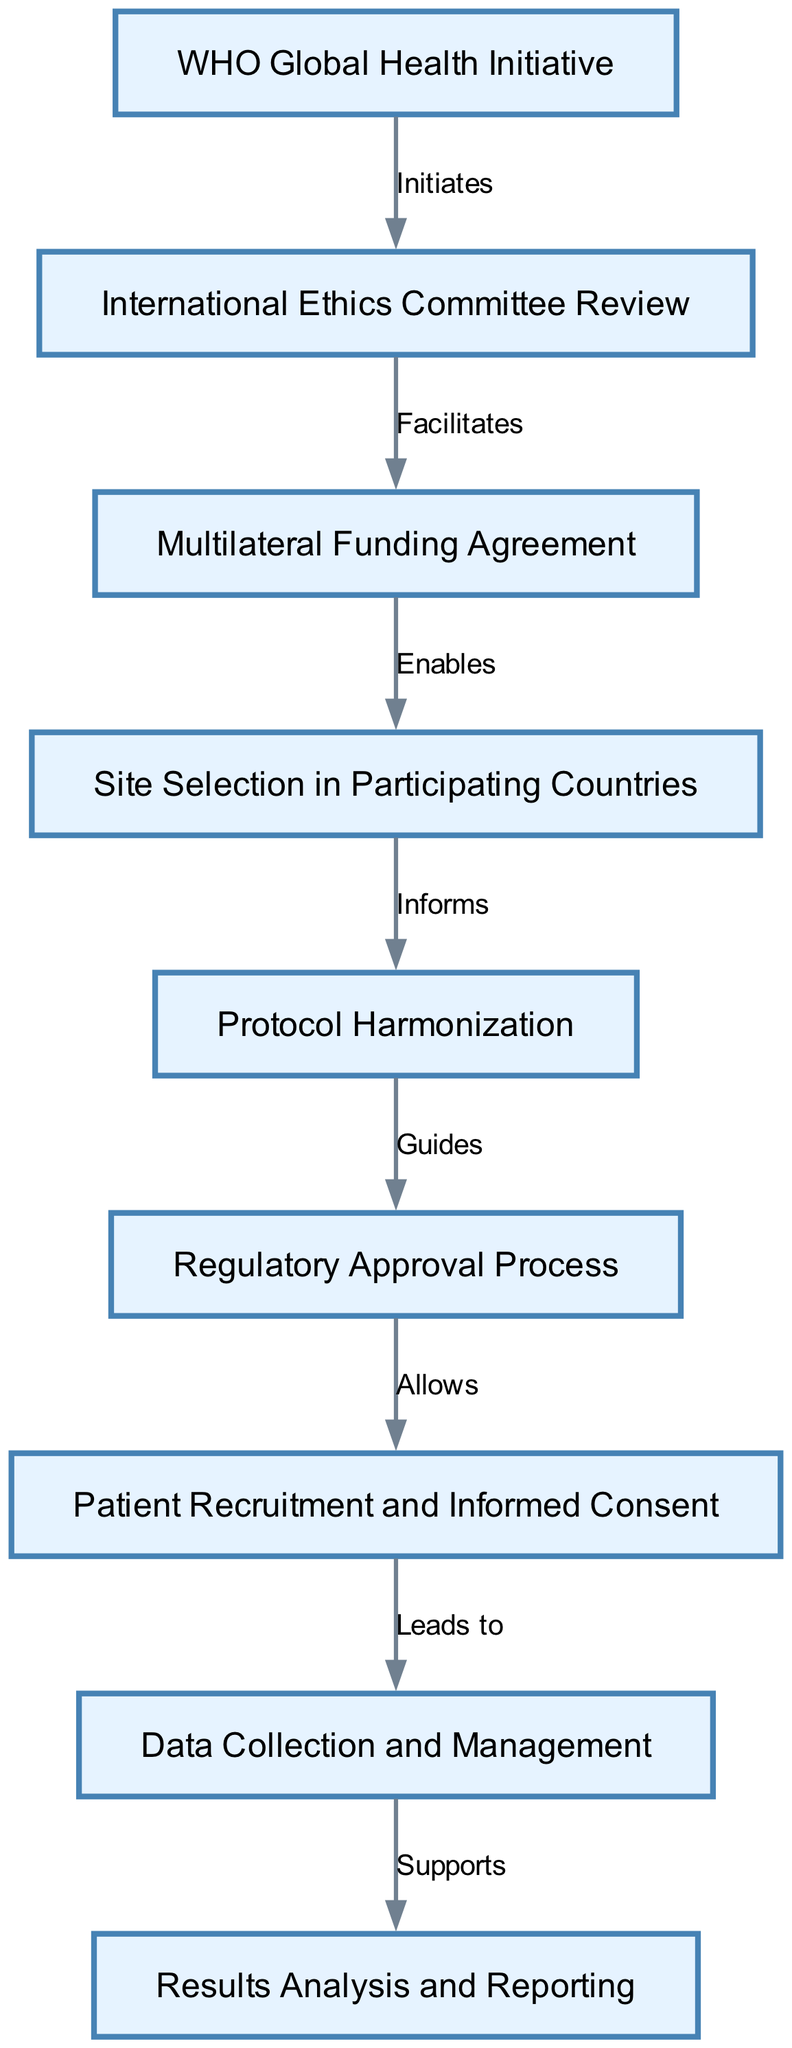What is the first step in the pathway? The first step in the pathway is initiated by the WHO Global Health Initiative, which sets the process in motion.
Answer: WHO Global Health Initiative How many nodes are in the clinical pathway diagram? The diagram contains a total of nine nodes, each representing a key element in the multinational clinical trial coordination pathway.
Answer: 9 Which node follows the International Ethics Committee Review? The node that follows the International Ethics Committee Review is the Multilateral Funding Agreement, as indicated by the directed edge connecting them.
Answer: Multilateral Funding Agreement What relationship does Site Selection in Participating Countries have with Protocol Harmonization? Site Selection in Participating Countries informs Protocol Harmonization, meaning that the selection process impacts how the study protocols are coordinated and standardized.
Answer: Informs What enables the Site Selection in Participating Countries? The enabling factor for Site Selection in Participating Countries is the Multilateral Funding Agreement, which provides the necessary resources and financial backing for the selection process.
Answer: Multilateral Funding Agreement Which process allows for Patient Recruitment and Informed Consent? The Regulatory Approval Process allows for Patient Recruitment and Informed Consent, as approval is required before recruitment can legally proceed.
Answer: Regulatory Approval Process What does Data Collection and Management support? Data Collection and Management supports the Results Analysis and Reporting process, as the data gathered is essential for analyzing and reporting the trial outcomes.
Answer: Results Analysis and Reporting How many edges are present in the diagram? The diagram features a total of eight edges, each representing a distinct relationship between the nodes that detail the flow of the clinical pathway.
Answer: 8 Which node is directly linked to Results Analysis and Reporting? The node directly linked to Results Analysis and Reporting is Data Collection and Management, which directly precedes it in the flow.
Answer: Data Collection and Management What guides the Regulatory Approval Process? The Protocol Harmonization guides the Regulatory Approval Process by ensuring that the study protocols are aligned with regulations across different countries, facilitating a smoother approval process.
Answer: Protocol Harmonization 